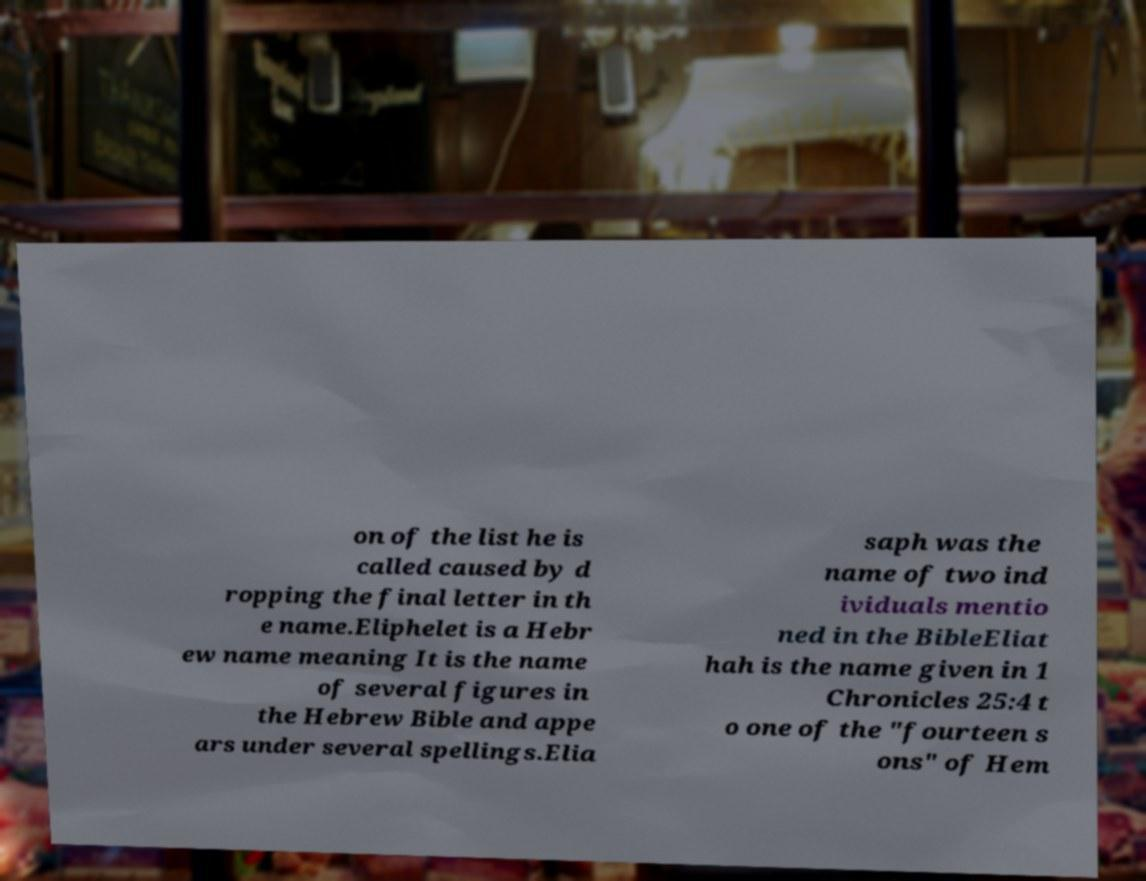Can you read and provide the text displayed in the image?This photo seems to have some interesting text. Can you extract and type it out for me? on of the list he is called caused by d ropping the final letter in th e name.Eliphelet is a Hebr ew name meaning It is the name of several figures in the Hebrew Bible and appe ars under several spellings.Elia saph was the name of two ind ividuals mentio ned in the BibleEliat hah is the name given in 1 Chronicles 25:4 t o one of the "fourteen s ons" of Hem 